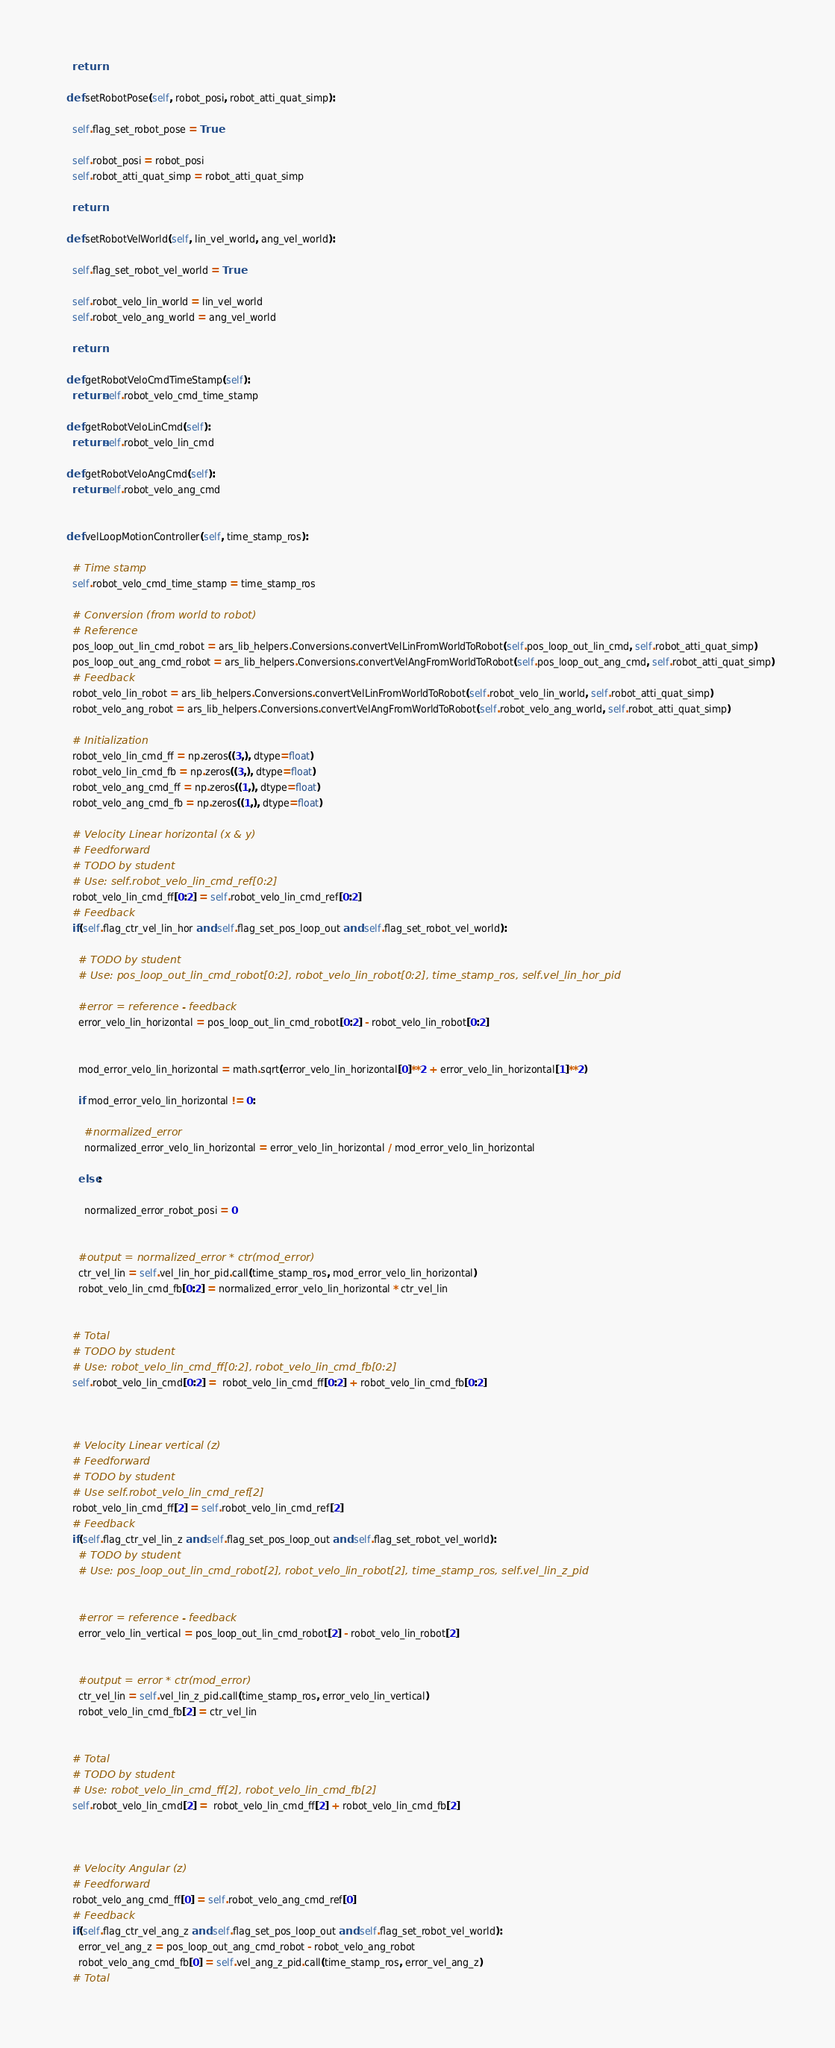Convert code to text. <code><loc_0><loc_0><loc_500><loc_500><_Python_>
    return

  def setRobotPose(self, robot_posi, robot_atti_quat_simp):
    
    self.flag_set_robot_pose = True

    self.robot_posi = robot_posi
    self.robot_atti_quat_simp = robot_atti_quat_simp

    return

  def setRobotVelWorld(self, lin_vel_world, ang_vel_world):

    self.flag_set_robot_vel_world = True

    self.robot_velo_lin_world = lin_vel_world
    self.robot_velo_ang_world = ang_vel_world

    return

  def getRobotVeloCmdTimeStamp(self):
    return self.robot_velo_cmd_time_stamp

  def getRobotVeloLinCmd(self):
    return self.robot_velo_lin_cmd

  def getRobotVeloAngCmd(self):
    return self.robot_velo_ang_cmd


  def velLoopMotionController(self, time_stamp_ros):

    # Time stamp
    self.robot_velo_cmd_time_stamp = time_stamp_ros

    # Conversion (from world to robot)
    # Reference
    pos_loop_out_lin_cmd_robot = ars_lib_helpers.Conversions.convertVelLinFromWorldToRobot(self.pos_loop_out_lin_cmd, self.robot_atti_quat_simp)
    pos_loop_out_ang_cmd_robot = ars_lib_helpers.Conversions.convertVelAngFromWorldToRobot(self.pos_loop_out_ang_cmd, self.robot_atti_quat_simp)
    # Feedback
    robot_velo_lin_robot = ars_lib_helpers.Conversions.convertVelLinFromWorldToRobot(self.robot_velo_lin_world, self.robot_atti_quat_simp)
    robot_velo_ang_robot = ars_lib_helpers.Conversions.convertVelAngFromWorldToRobot(self.robot_velo_ang_world, self.robot_atti_quat_simp)

    # Initialization
    robot_velo_lin_cmd_ff = np.zeros((3,), dtype=float)
    robot_velo_lin_cmd_fb = np.zeros((3,), dtype=float)
    robot_velo_ang_cmd_ff = np.zeros((1,), dtype=float)
    robot_velo_ang_cmd_fb = np.zeros((1,), dtype=float)

    # Velocity Linear horizontal (x & y)
    # Feedforward
    # TODO by student
    # Use: self.robot_velo_lin_cmd_ref[0:2]
    robot_velo_lin_cmd_ff[0:2] = self.robot_velo_lin_cmd_ref[0:2]
    # Feedback
    if(self.flag_ctr_vel_lin_hor and self.flag_set_pos_loop_out and self.flag_set_robot_vel_world):
      
      # TODO by student
      # Use: pos_loop_out_lin_cmd_robot[0:2], robot_velo_lin_robot[0:2], time_stamp_ros, self.vel_lin_hor_pid
      
      #error = reference - feedback
      error_velo_lin_horizontal = pos_loop_out_lin_cmd_robot[0:2] - robot_velo_lin_robot[0:2]


      mod_error_velo_lin_horizontal = math.sqrt(error_velo_lin_horizontal[0]**2 + error_velo_lin_horizontal[1]**2) 
  
      if mod_error_velo_lin_horizontal != 0:

        #normalized_error  
        normalized_error_velo_lin_horizontal = error_velo_lin_horizontal / mod_error_velo_lin_horizontal
       
      else: 

        normalized_error_robot_posi = 0

      
      #output = normalized_error * ctr(mod_error)
      ctr_vel_lin = self.vel_lin_hor_pid.call(time_stamp_ros, mod_error_velo_lin_horizontal)
      robot_velo_lin_cmd_fb[0:2] = normalized_error_velo_lin_horizontal * ctr_vel_lin
    

    # Total
    # TODO by student
    # Use: robot_velo_lin_cmd_ff[0:2], robot_velo_lin_cmd_fb[0:2]
    self.robot_velo_lin_cmd[0:2] =  robot_velo_lin_cmd_ff[0:2] + robot_velo_lin_cmd_fb[0:2]

   

    # Velocity Linear vertical (z)
    # Feedforward
    # TODO by student
    # Use self.robot_velo_lin_cmd_ref[2]
    robot_velo_lin_cmd_ff[2] = self.robot_velo_lin_cmd_ref[2]
    # Feedback
    if(self.flag_ctr_vel_lin_z and self.flag_set_pos_loop_out and self.flag_set_robot_vel_world):
      # TODO by student
      # Use: pos_loop_out_lin_cmd_robot[2], robot_velo_lin_robot[2], time_stamp_ros, self.vel_lin_z_pid


      #error = reference - feedback
      error_velo_lin_vertical = pos_loop_out_lin_cmd_robot[2] - robot_velo_lin_robot[2]

      
      #output = error * ctr(mod_error)
      ctr_vel_lin = self.vel_lin_z_pid.call(time_stamp_ros, error_velo_lin_vertical)
      robot_velo_lin_cmd_fb[2] = ctr_vel_lin
    

    # Total
    # TODO by student
    # Use: robot_velo_lin_cmd_ff[2], robot_velo_lin_cmd_fb[2]
    self.robot_velo_lin_cmd[2] =  robot_velo_lin_cmd_ff[2] + robot_velo_lin_cmd_fb[2]



    # Velocity Angular (z)
    # Feedforward
    robot_velo_ang_cmd_ff[0] = self.robot_velo_ang_cmd_ref[0]
    # Feedback
    if(self.flag_ctr_vel_ang_z and self.flag_set_pos_loop_out and self.flag_set_robot_vel_world):
      error_vel_ang_z = pos_loop_out_ang_cmd_robot - robot_velo_ang_robot
      robot_velo_ang_cmd_fb[0] = self.vel_ang_z_pid.call(time_stamp_ros, error_vel_ang_z)
    # Total</code> 